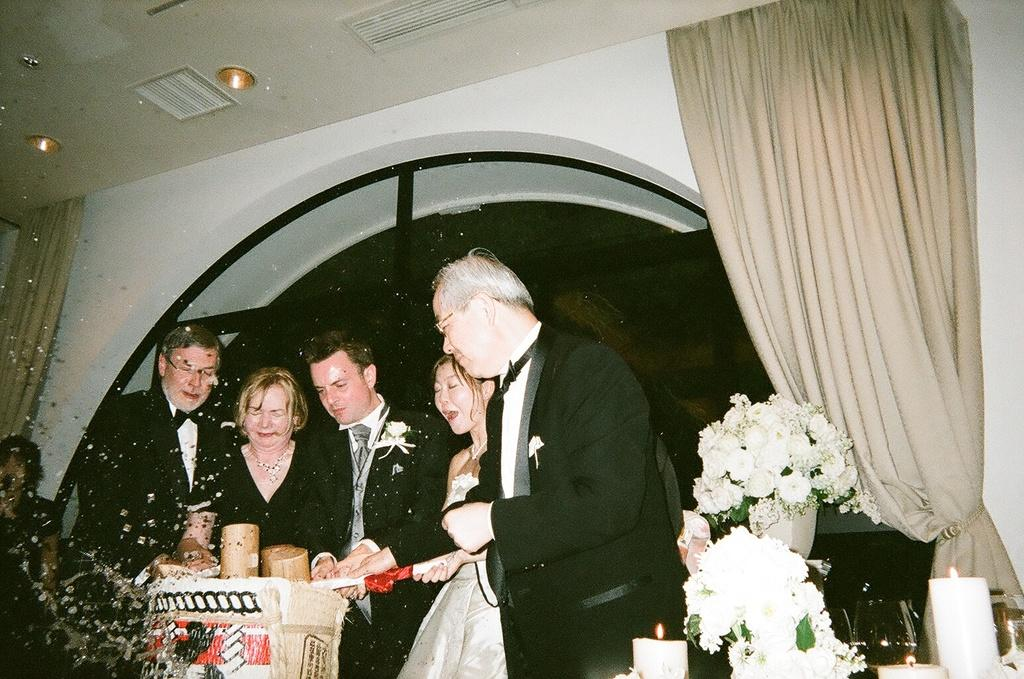Who or what is present in the image? There are people in the image. What other objects can be seen in the image? There are flowers and candles in the image. Where are the flowers and candles located? The flowers and candles are on the right side of the image. What else is visible in the image? There is a curtain and lights visible in the image. What type of land can be seen in the image? There is no land visible in the image; it features people, flowers, candles, a curtain, and lights. 